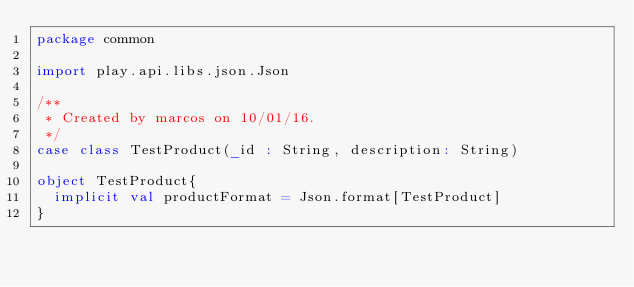<code> <loc_0><loc_0><loc_500><loc_500><_Scala_>package common

import play.api.libs.json.Json

/**
 * Created by marcos on 10/01/16.
 */
case class TestProduct(_id : String, description: String)

object TestProduct{
  implicit val productFormat = Json.format[TestProduct]
}
</code> 